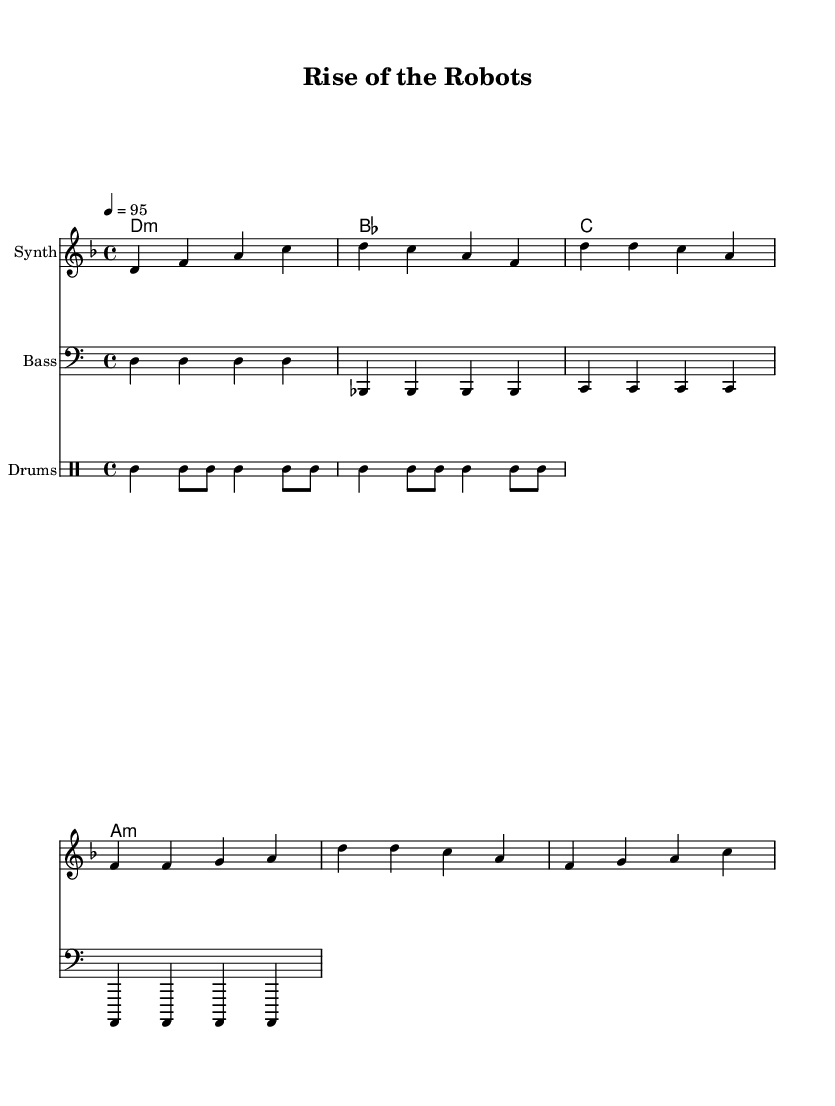What is the key signature of this music? The key signature is identified by the 'd' in the first staff, which indicates it has two flats (B flat and E flat). This defines the key of D minor.
Answer: D minor What is the time signature of the piece? The time signature is specified as 4/4 at the beginning of the score, meaning there are four beats per measure and the quarter note gets one beat.
Answer: 4/4 What is the tempo marking of the piece? The tempo marking is indicated as 4 = 95, which means there are 95 beats per minute in a quarter note fashion.
Answer: 95 How many instruments are featured in the score? The score includes three distinct instruments: Synth, Bass, and Drums, as indicated by the names above their respective staves.
Answer: Three What is the main theme of the chorus melody? The main theme can be inferred from the repeated notes and structured pattern in the melody section labeled as "Chorus." The phrases start and end with the same notes, creating a catchy hook.
Answer: Repetitive theme How does the drum rhythm contribute to the energy of the piece? The drum rhythm, featuring a combination of bass and snare hits with high-hat accents, provides a driving beat that supports the upbeat energy typical of high-energy hip-hop and encourages movement.
Answer: Driving beat What is the significance of using a minor key in a rap song? Using a minor key often adds emotional depth and intensity to the music, creating a contrast with the upbeat and energetic rhythm, which is a common technique in rap to evoke strong feelings.
Answer: Emotional depth 